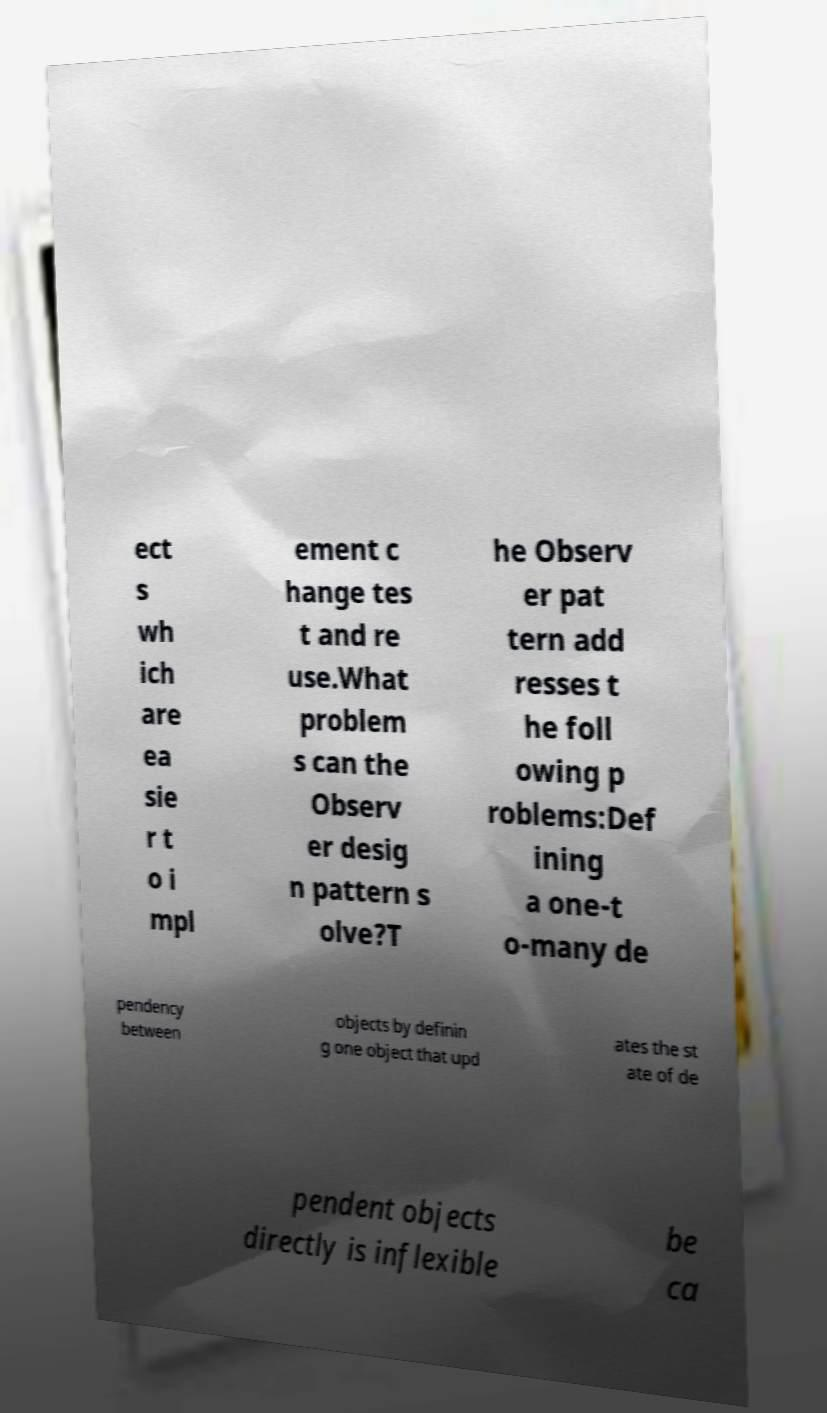Could you assist in decoding the text presented in this image and type it out clearly? ect s wh ich are ea sie r t o i mpl ement c hange tes t and re use.What problem s can the Observ er desig n pattern s olve?T he Observ er pat tern add resses t he foll owing p roblems:Def ining a one-t o-many de pendency between objects by definin g one object that upd ates the st ate of de pendent objects directly is inflexible be ca 